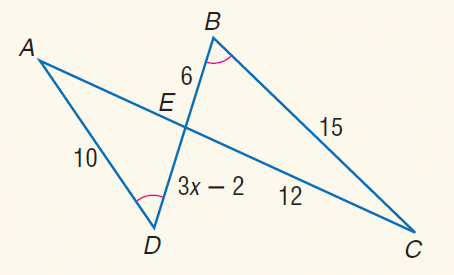Answer the mathemtical geometry problem and directly provide the correct option letter.
Question: Find x.
Choices: A: 1.5 B: 2 C: 3 D: 4 B 